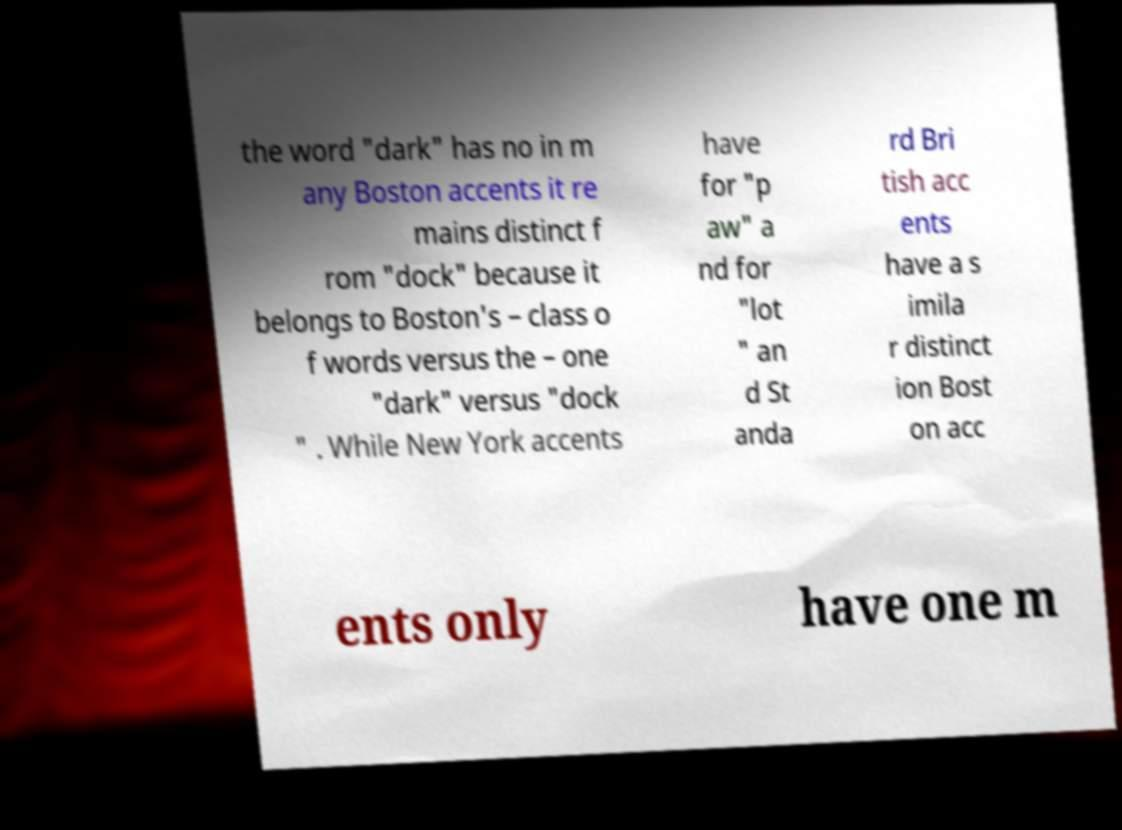I need the written content from this picture converted into text. Can you do that? the word "dark" has no in m any Boston accents it re mains distinct f rom "dock" because it belongs to Boston's – class o f words versus the – one "dark" versus "dock " . While New York accents have for "p aw" a nd for "lot " an d St anda rd Bri tish acc ents have a s imila r distinct ion Bost on acc ents only have one m 